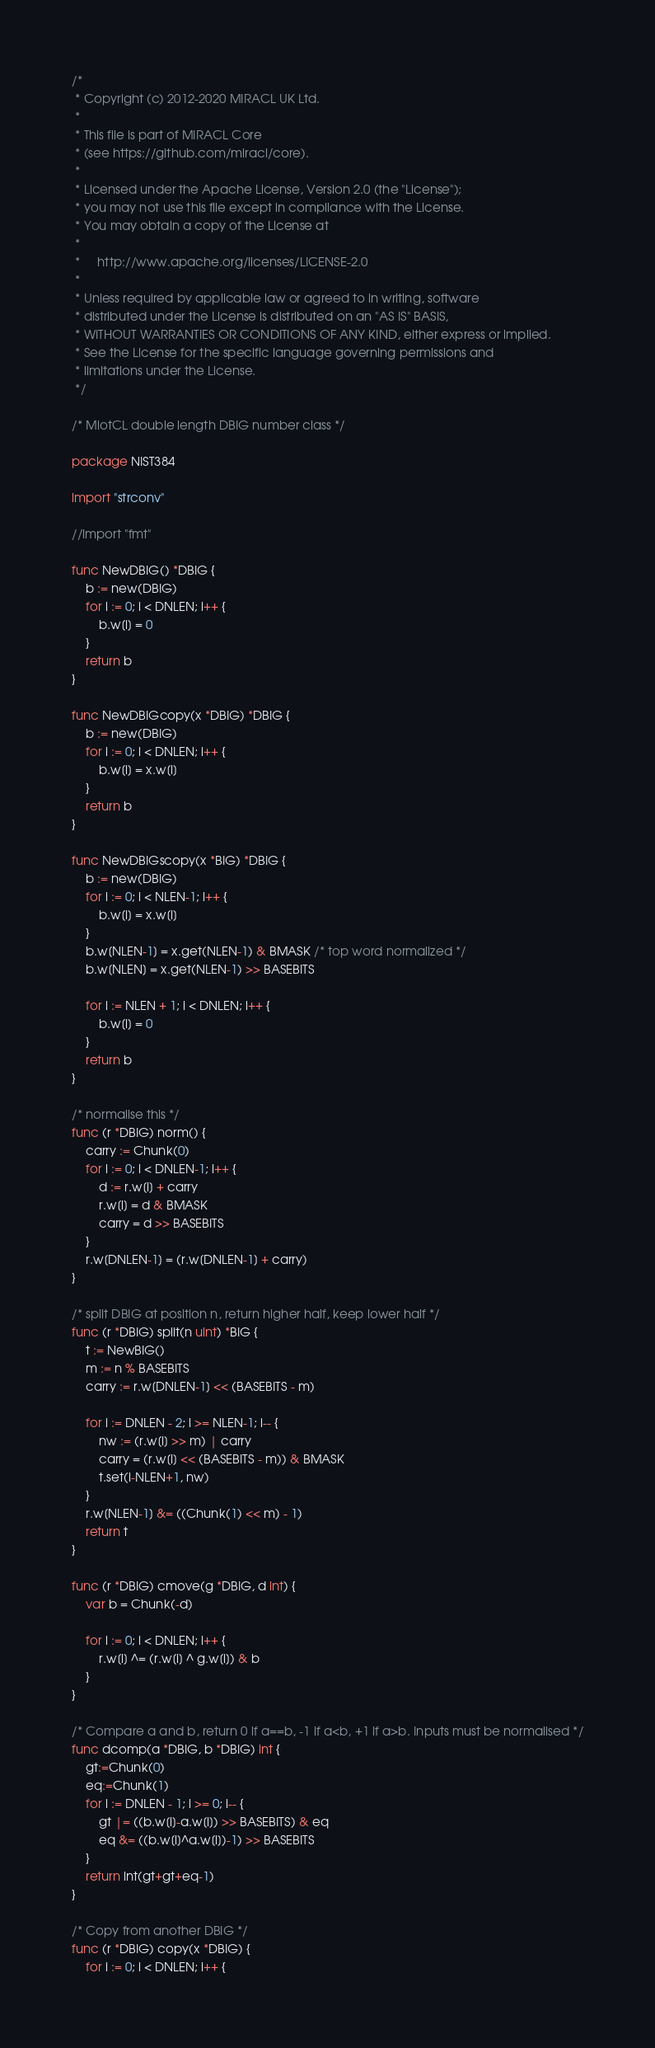<code> <loc_0><loc_0><loc_500><loc_500><_Go_>/*
 * Copyright (c) 2012-2020 MIRACL UK Ltd.
 *
 * This file is part of MIRACL Core
 * (see https://github.com/miracl/core).
 *
 * Licensed under the Apache License, Version 2.0 (the "License");
 * you may not use this file except in compliance with the License.
 * You may obtain a copy of the License at
 *
 *     http://www.apache.org/licenses/LICENSE-2.0
 *
 * Unless required by applicable law or agreed to in writing, software
 * distributed under the License is distributed on an "AS IS" BASIS,
 * WITHOUT WARRANTIES OR CONDITIONS OF ANY KIND, either express or implied.
 * See the License for the specific language governing permissions and
 * limitations under the License.
 */

/* MiotCL double length DBIG number class */

package NIST384

import "strconv"

//import "fmt"

func NewDBIG() *DBIG {
	b := new(DBIG)
	for i := 0; i < DNLEN; i++ {
		b.w[i] = 0
	}
	return b
}

func NewDBIGcopy(x *DBIG) *DBIG {
	b := new(DBIG)
	for i := 0; i < DNLEN; i++ {
		b.w[i] = x.w[i]
	}
	return b
}

func NewDBIGscopy(x *BIG) *DBIG {
	b := new(DBIG)
	for i := 0; i < NLEN-1; i++ {
		b.w[i] = x.w[i]
	}
	b.w[NLEN-1] = x.get(NLEN-1) & BMASK /* top word normalized */
	b.w[NLEN] = x.get(NLEN-1) >> BASEBITS

	for i := NLEN + 1; i < DNLEN; i++ {
		b.w[i] = 0
	}
	return b
}

/* normalise this */
func (r *DBIG) norm() {
	carry := Chunk(0)
	for i := 0; i < DNLEN-1; i++ {
		d := r.w[i] + carry
		r.w[i] = d & BMASK
		carry = d >> BASEBITS
	}
	r.w[DNLEN-1] = (r.w[DNLEN-1] + carry)
}

/* split DBIG at position n, return higher half, keep lower half */
func (r *DBIG) split(n uint) *BIG {
	t := NewBIG()
	m := n % BASEBITS
	carry := r.w[DNLEN-1] << (BASEBITS - m)

	for i := DNLEN - 2; i >= NLEN-1; i-- {
		nw := (r.w[i] >> m) | carry
		carry = (r.w[i] << (BASEBITS - m)) & BMASK
		t.set(i-NLEN+1, nw)
	}
	r.w[NLEN-1] &= ((Chunk(1) << m) - 1)
	return t
}

func (r *DBIG) cmove(g *DBIG, d int) {
	var b = Chunk(-d)

	for i := 0; i < DNLEN; i++ {
		r.w[i] ^= (r.w[i] ^ g.w[i]) & b
	}
}

/* Compare a and b, return 0 if a==b, -1 if a<b, +1 if a>b. Inputs must be normalised */
func dcomp(a *DBIG, b *DBIG) int {
	gt:=Chunk(0)
	eq:=Chunk(1)
	for i := DNLEN - 1; i >= 0; i-- {
		gt |= ((b.w[i]-a.w[i]) >> BASEBITS) & eq
		eq &= ((b.w[i]^a.w[i])-1) >> BASEBITS
	}
	return int(gt+gt+eq-1)
}

/* Copy from another DBIG */
func (r *DBIG) copy(x *DBIG) {
	for i := 0; i < DNLEN; i++ {</code> 